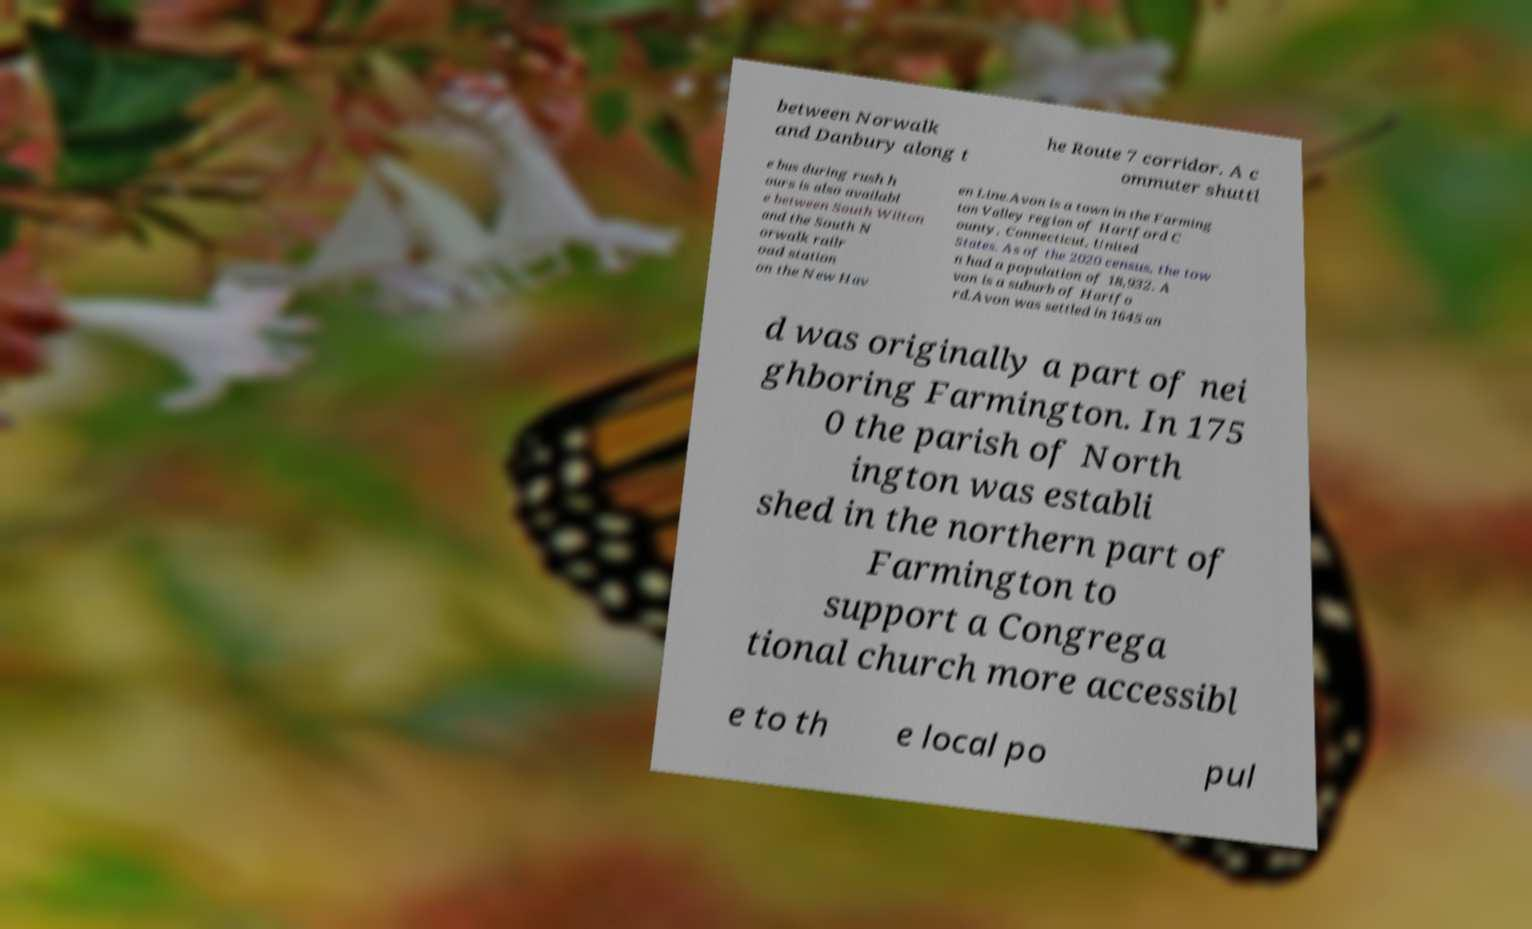Could you assist in decoding the text presented in this image and type it out clearly? between Norwalk and Danbury along t he Route 7 corridor. A c ommuter shuttl e bus during rush h ours is also availabl e between South Wilton and the South N orwalk railr oad station on the New Hav en Line.Avon is a town in the Farming ton Valley region of Hartford C ounty, Connecticut, United States. As of the 2020 census, the tow n had a population of 18,932. A von is a suburb of Hartfo rd.Avon was settled in 1645 an d was originally a part of nei ghboring Farmington. In 175 0 the parish of North ington was establi shed in the northern part of Farmington to support a Congrega tional church more accessibl e to th e local po pul 